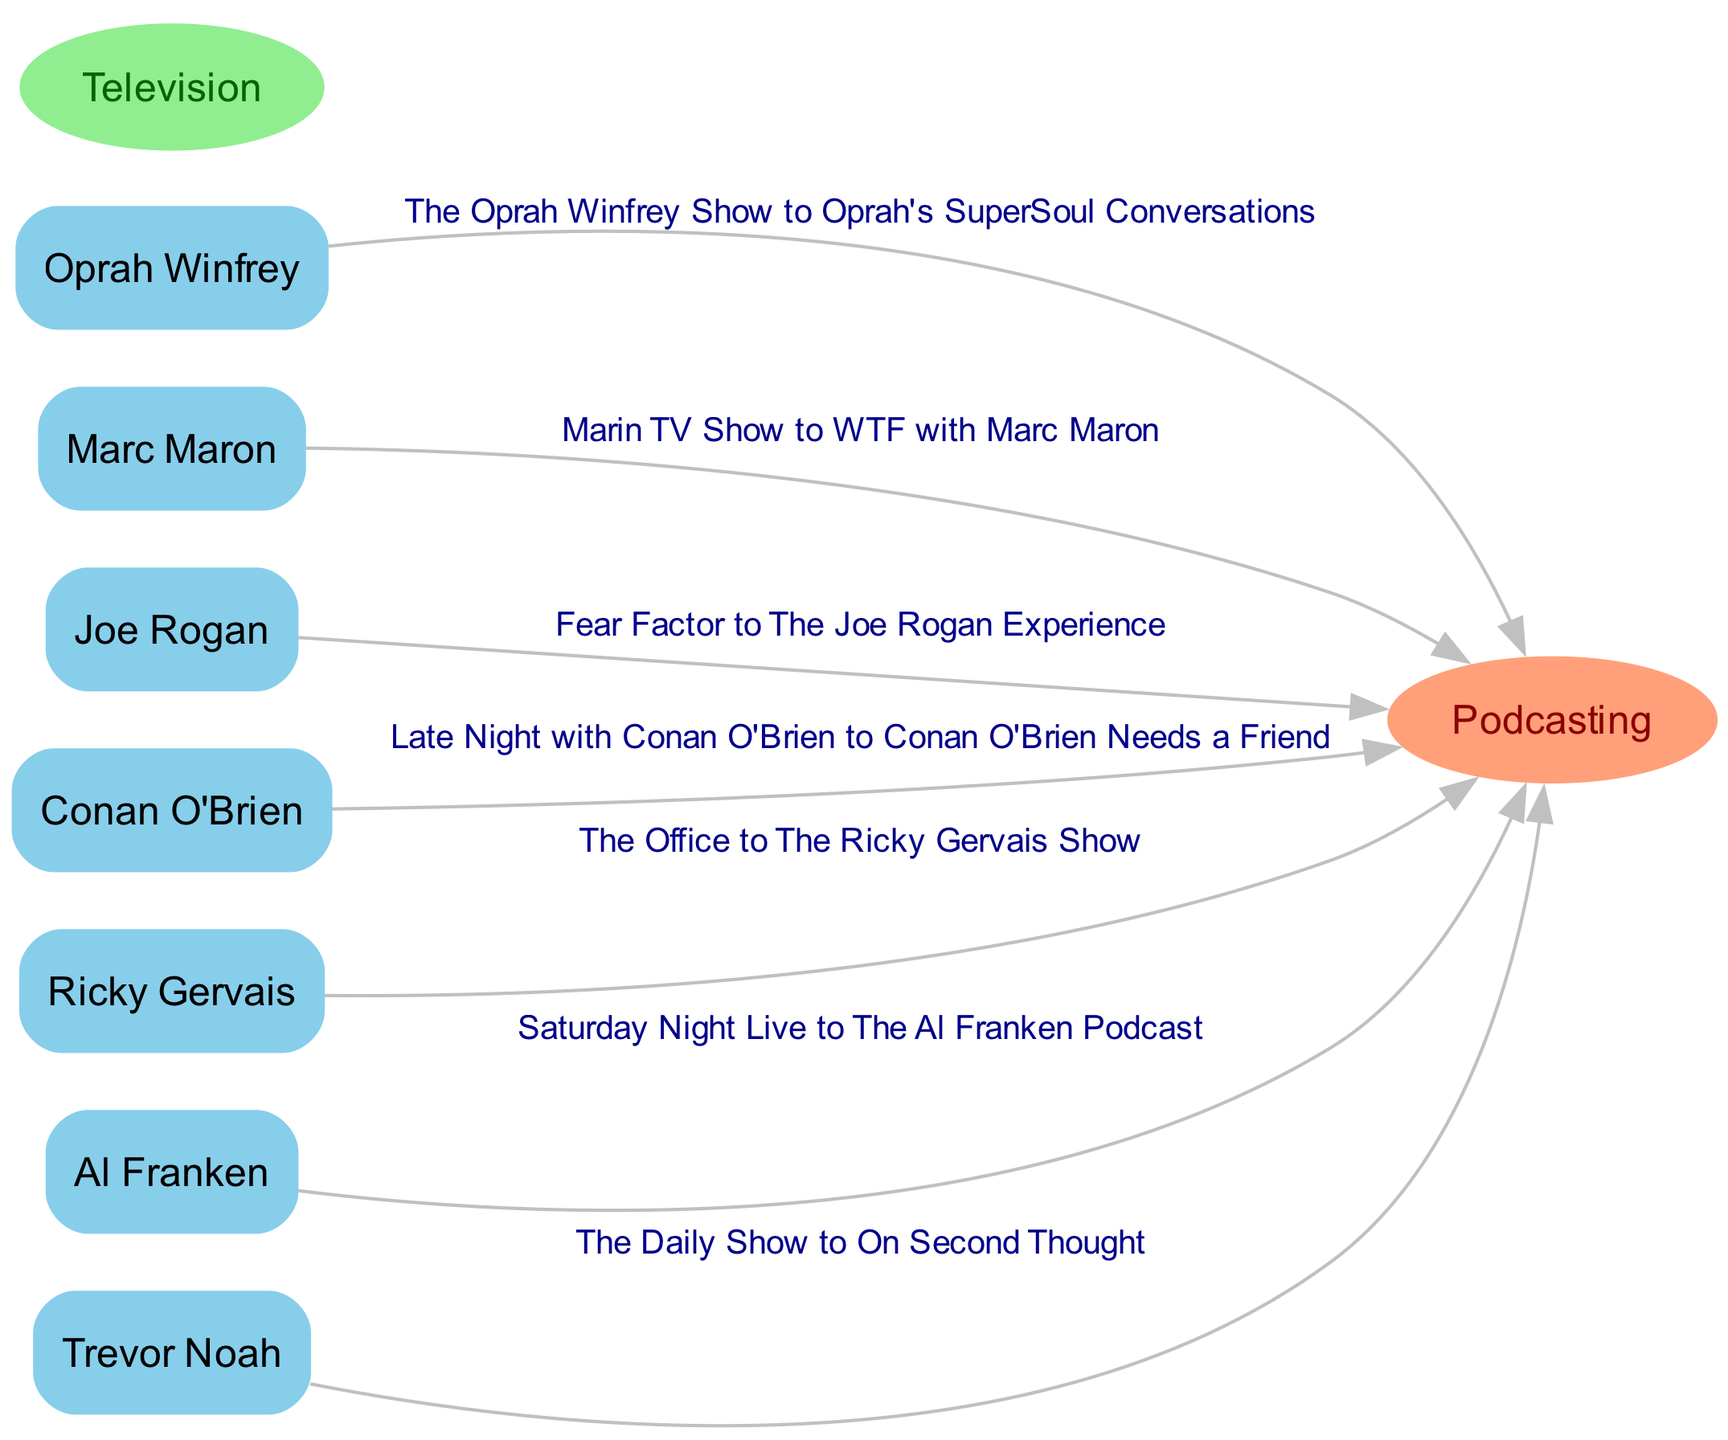What is the number of prominent media figures transitioning from TV to podcasting? The diagram lists seven media figures by showing their names as nodes, indicating that each has made a transition from TV to podcasting. Counting these nodes results in a total of seven figures.
Answer: 7 Which media figure transitioned from "Fear Factor"? The edge connected from "Fear Factor" leads to the node for "The Joe Rogan Experience," indicating that Joe Rogan transitioned from this television show to his podcast.
Answer: Joe Rogan What podcast is associated with Trevor Noah? In the diagram, there's an edge leading from Trevor Noah that connects to "On Second Thought," indicating that this is the podcast he created after his work on TV.
Answer: On Second Thought Who transitioned from "The Office"? The diagram shows an edge from "The Office" to the podcast node for Ricky Gervais, indicating that he transitioned to his podcast after his stint on the TV show.
Answer: Ricky Gervais What is the relationship label between "Conan O'Brien" and the podcasting node? The edge connected to Conan O'Brien includes the label "Late Night with Conan O'Brien to Conan O'Brien Needs a Friend," indicating his transition from the late-night show to his podcast.
Answer: Late Night with Conan O'Brien to Conan O'Brien Needs a Friend Which media figure transitioned to a podcast from “Saturday Night Live”? The edge from "Saturday Night Live" links to "The Al Franken Podcast," indicating that Al Franken made this transition after his time on the show.
Answer: Al Franken How many edges are shown in the diagram? The diagram presents edges that connect each media figure to their respective podcasts. Counting these edges gives a total of seven transitions depicted.
Answer: 7 